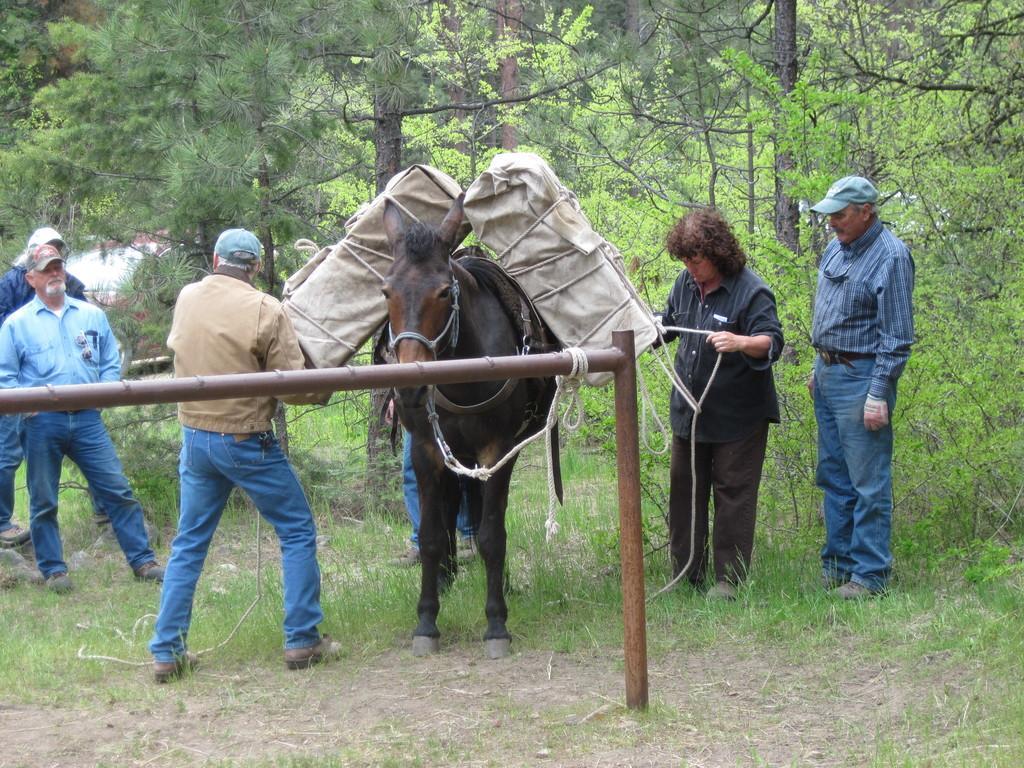In one or two sentences, can you explain what this image depicts? In this image we can see a few people standing, there is an animal, on the animal we can see some objects and a stand on the ground, in the background we can see some trees. 